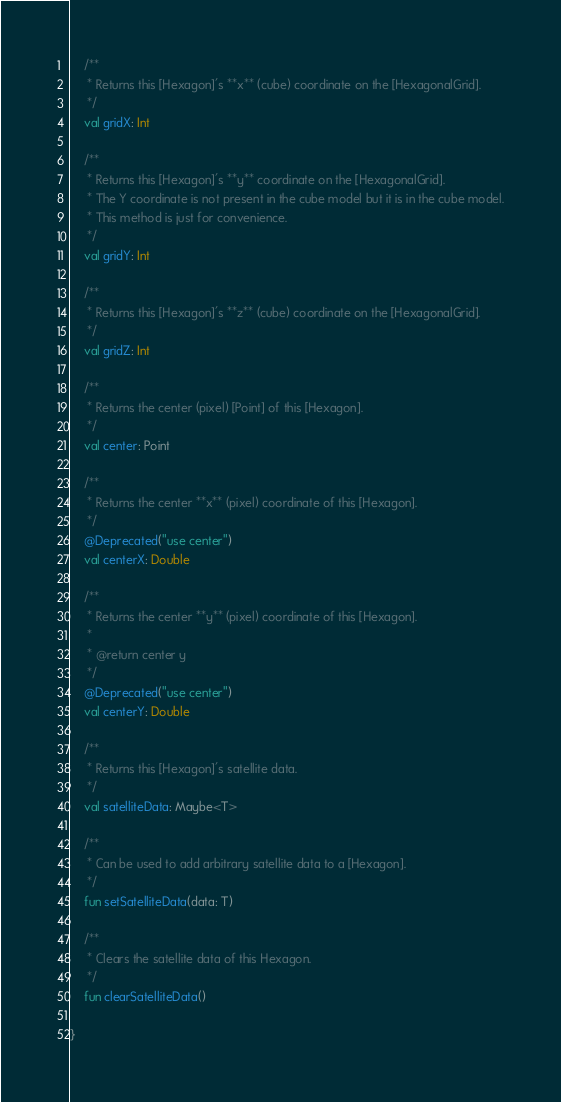<code> <loc_0><loc_0><loc_500><loc_500><_Kotlin_>
    /**
     * Returns this [Hexagon]'s **x** (cube) coordinate on the [HexagonalGrid].
     */
    val gridX: Int

    /**
     * Returns this [Hexagon]'s **y** coordinate on the [HexagonalGrid].
     * The Y coordinate is not present in the cube model but it is in the cube model.
     * This method is just for convenience.
     */
    val gridY: Int

    /**
     * Returns this [Hexagon]'s **z** (cube) coordinate on the [HexagonalGrid].
     */
    val gridZ: Int

    /**
     * Returns the center (pixel) [Point] of this [Hexagon].
     */
    val center: Point

    /**
     * Returns the center **x** (pixel) coordinate of this [Hexagon].
     */
    @Deprecated("use center")
    val centerX: Double

    /**
     * Returns the center **y** (pixel) coordinate of this [Hexagon].
     *
     * @return center y
     */
    @Deprecated("use center")
    val centerY: Double

    /**
     * Returns this [Hexagon]'s satellite data.
     */
    val satelliteData: Maybe<T>

    /**
     * Can be used to add arbitrary satellite data to a [Hexagon].
     */
    fun setSatelliteData(data: T)

    /**
     * Clears the satellite data of this Hexagon.
     */
    fun clearSatelliteData()

}
</code> 